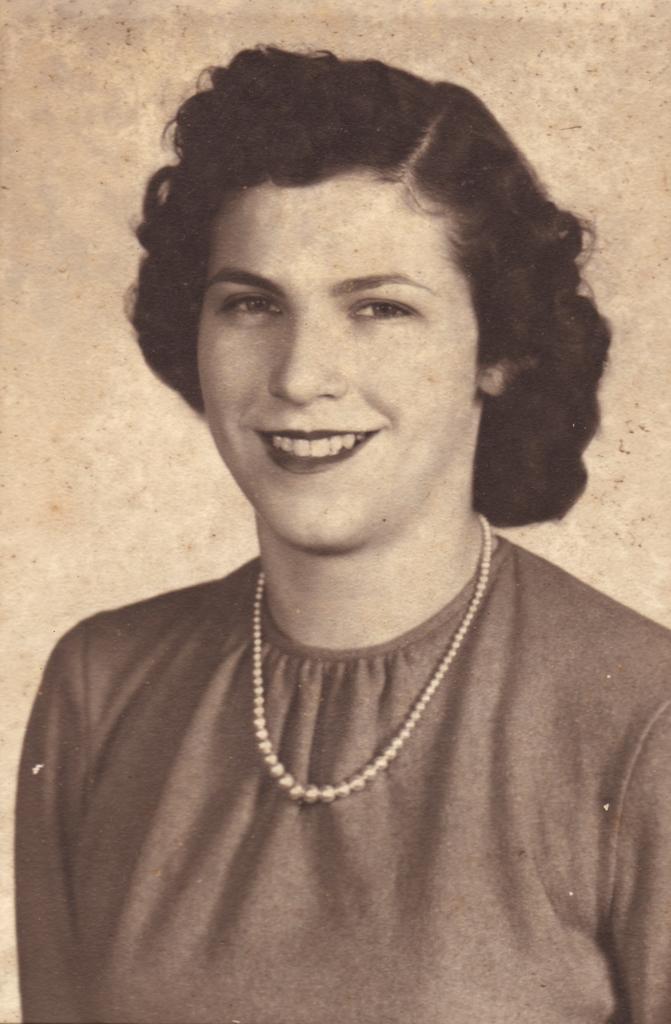How would you summarize this image in a sentence or two? There is a woman in the foreground area of the image. 